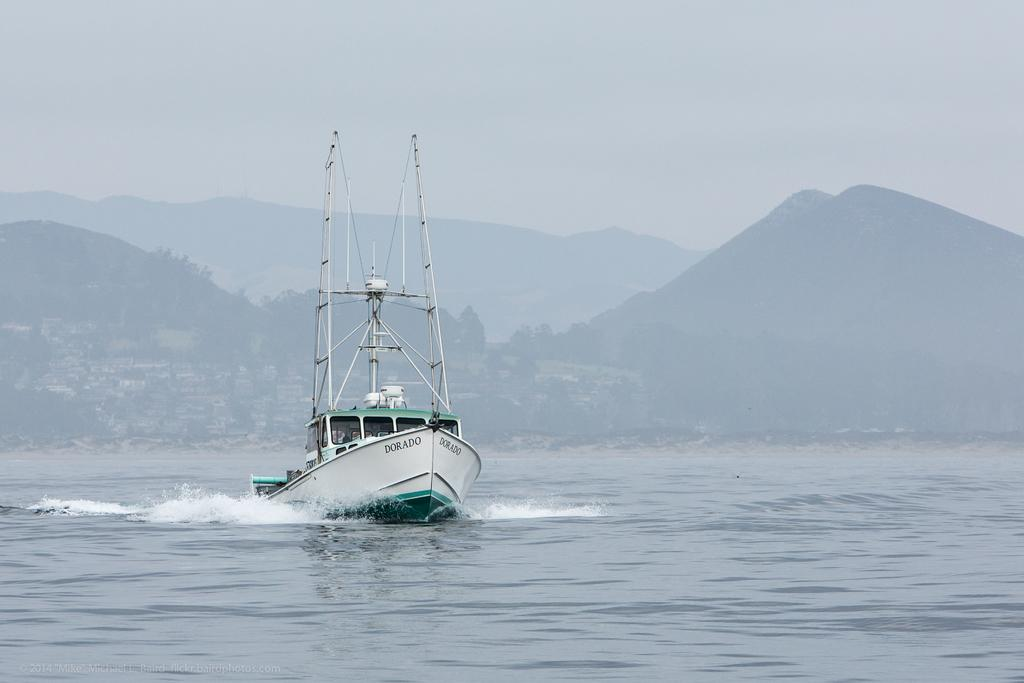What is the main subject of the image? The main subject of the image is a boat. What is the boat doing in the image? The boat is moving on the water in the image. What can be seen in the background of the image? There are mountains, trees, and houses visible in the background of the image. What type of noise can be heard coming from the park in the image? There is no park present in the image, so it's not possible to determine what, if any, noise might be heard. 